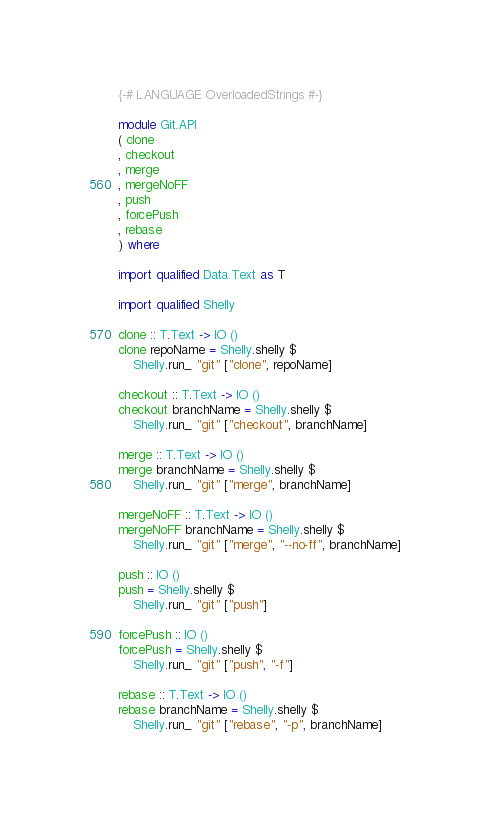Convert code to text. <code><loc_0><loc_0><loc_500><loc_500><_Haskell_>{-# LANGUAGE OverloadedStrings #-}

module Git.API
( clone
, checkout
, merge
, mergeNoFF
, push
, forcePush
, rebase
) where

import qualified Data.Text as T

import qualified Shelly

clone :: T.Text -> IO ()
clone repoName = Shelly.shelly $
    Shelly.run_ "git" ["clone", repoName]

checkout :: T.Text -> IO ()
checkout branchName = Shelly.shelly $
    Shelly.run_ "git" ["checkout", branchName]

merge :: T.Text -> IO ()
merge branchName = Shelly.shelly $
    Shelly.run_ "git" ["merge", branchName]

mergeNoFF :: T.Text -> IO ()
mergeNoFF branchName = Shelly.shelly $
    Shelly.run_ "git" ["merge", "--no-ff", branchName]

push :: IO ()
push = Shelly.shelly $
    Shelly.run_ "git" ["push"]

forcePush :: IO ()
forcePush = Shelly.shelly $
    Shelly.run_ "git" ["push", "-f"]

rebase :: T.Text -> IO ()
rebase branchName = Shelly.shelly $
    Shelly.run_ "git" ["rebase", "-p", branchName]
</code> 